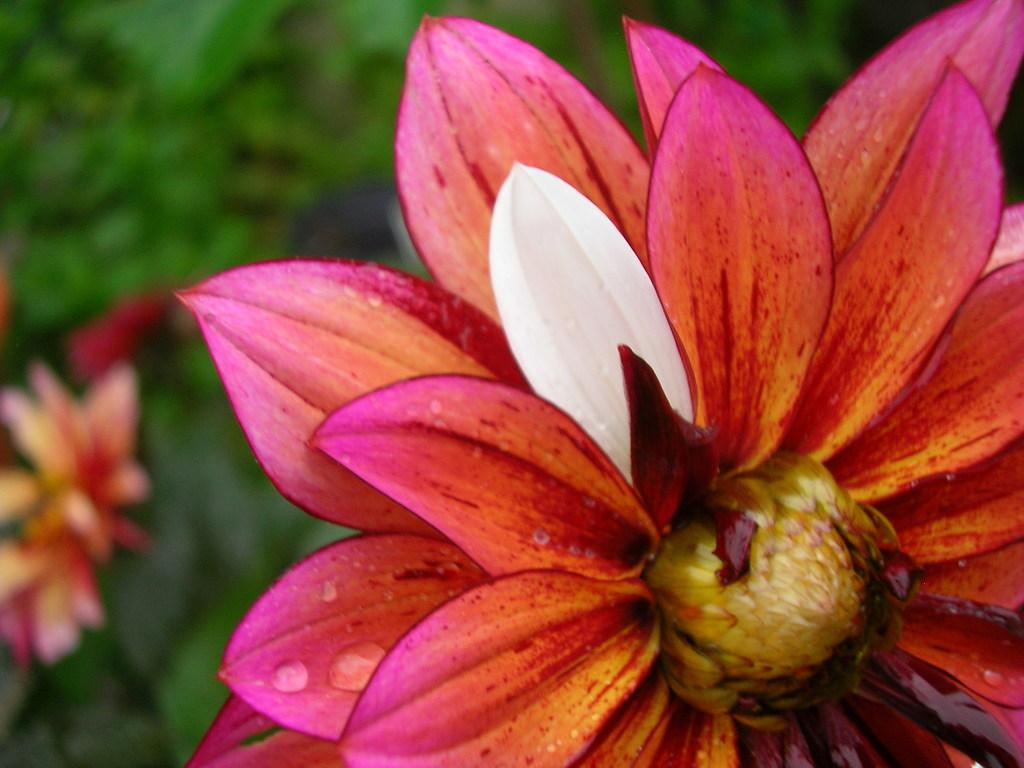What is the main subject in the front of the image? There is a flower in the front of the image. What can be seen in the background of the image? There is a tree in the background of the image. What part of the flower is visible in the image? The petals of the flower are visible in the image. How many balls are being used in the volleyball game in the image? There is no volleyball game or balls present in the image; it features a flower and a tree. Can you see a rifle in the image? There is no rifle present in the image. 